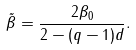<formula> <loc_0><loc_0><loc_500><loc_500>\tilde { \beta } = \frac { 2 \beta _ { 0 } } { 2 - ( q - 1 ) d } .</formula> 